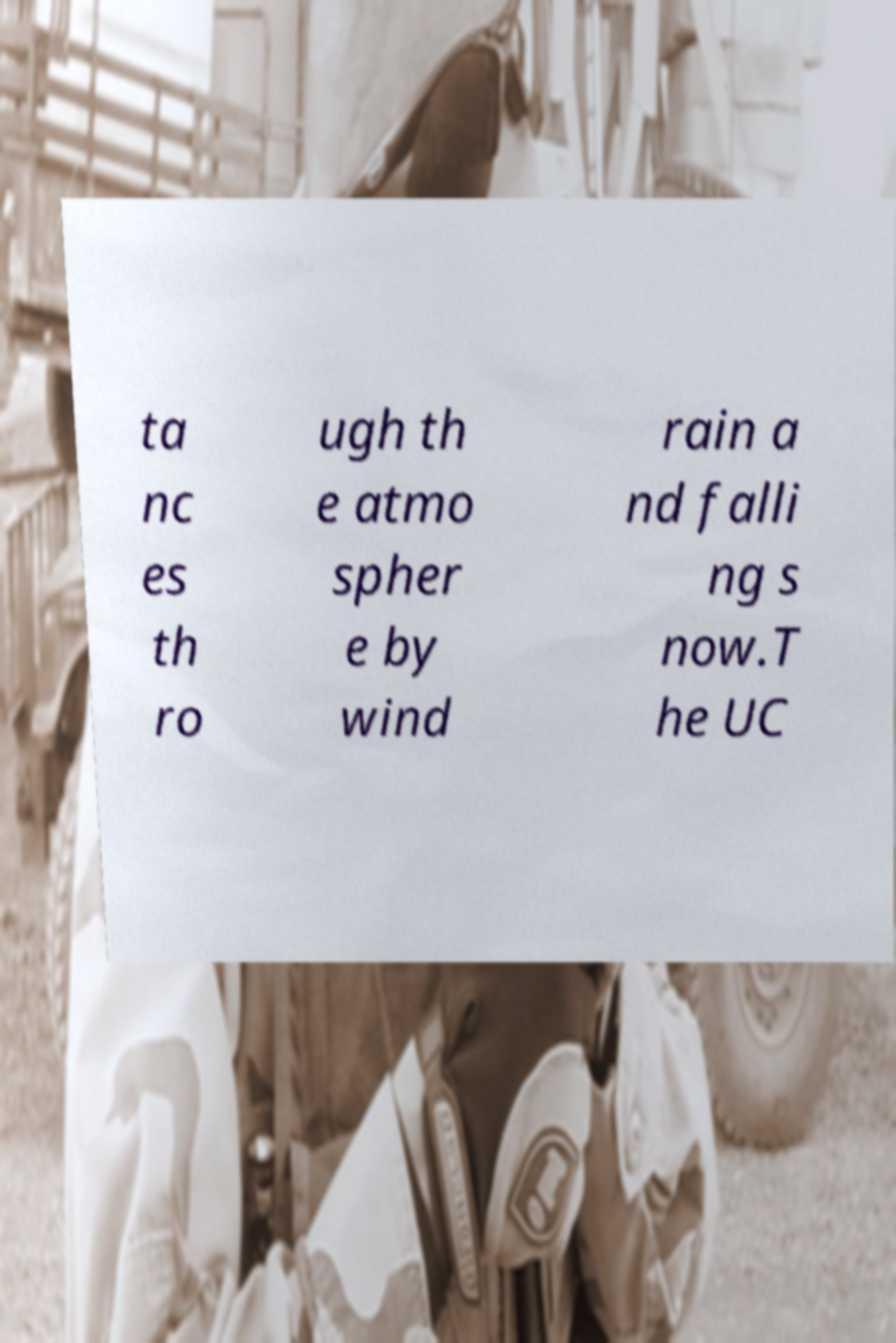Could you assist in decoding the text presented in this image and type it out clearly? ta nc es th ro ugh th e atmo spher e by wind rain a nd falli ng s now.T he UC 